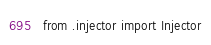Convert code to text. <code><loc_0><loc_0><loc_500><loc_500><_Python_>from .injector import Injector
</code> 